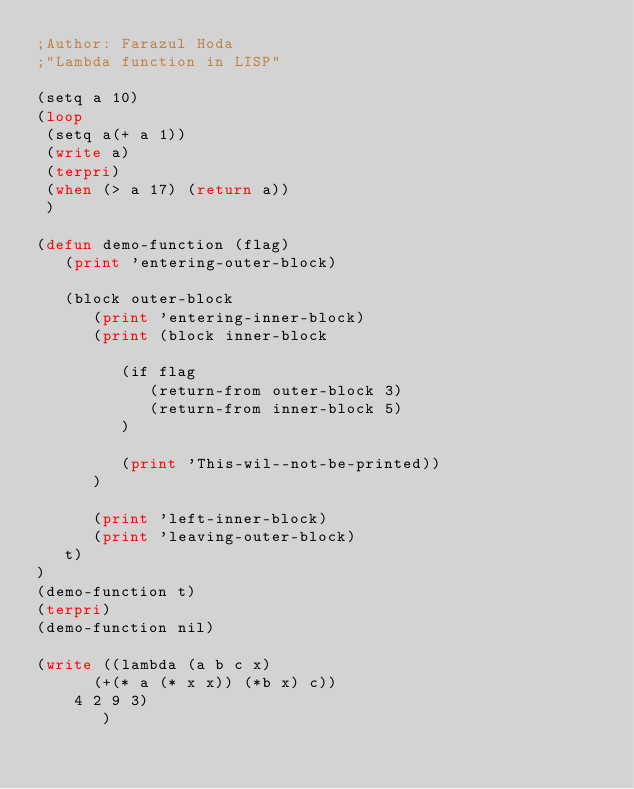Convert code to text. <code><loc_0><loc_0><loc_500><loc_500><_Lisp_>;Author: Farazul Hoda
;"Lambda function in LISP"

(setq a 10)
(loop
 (setq a(+ a 1))
 (write a)
 (terpri)
 (when (> a 17) (return a))
 )

(defun demo-function (flag)
   (print 'entering-outer-block)
   
   (block outer-block
      (print 'entering-inner-block)
      (print (block inner-block

         (if flag
            (return-from outer-block 3)
            (return-from inner-block 5)
         )

         (print 'This-wil--not-be-printed))
      )

      (print 'left-inner-block)
      (print 'leaving-outer-block)
   t)
)
(demo-function t)
(terpri)
(demo-function nil) 

(write ((lambda (a b c x)
	  (+(* a (* x x)) (*b x) c))
	4 2 9 3)
       )
</code> 